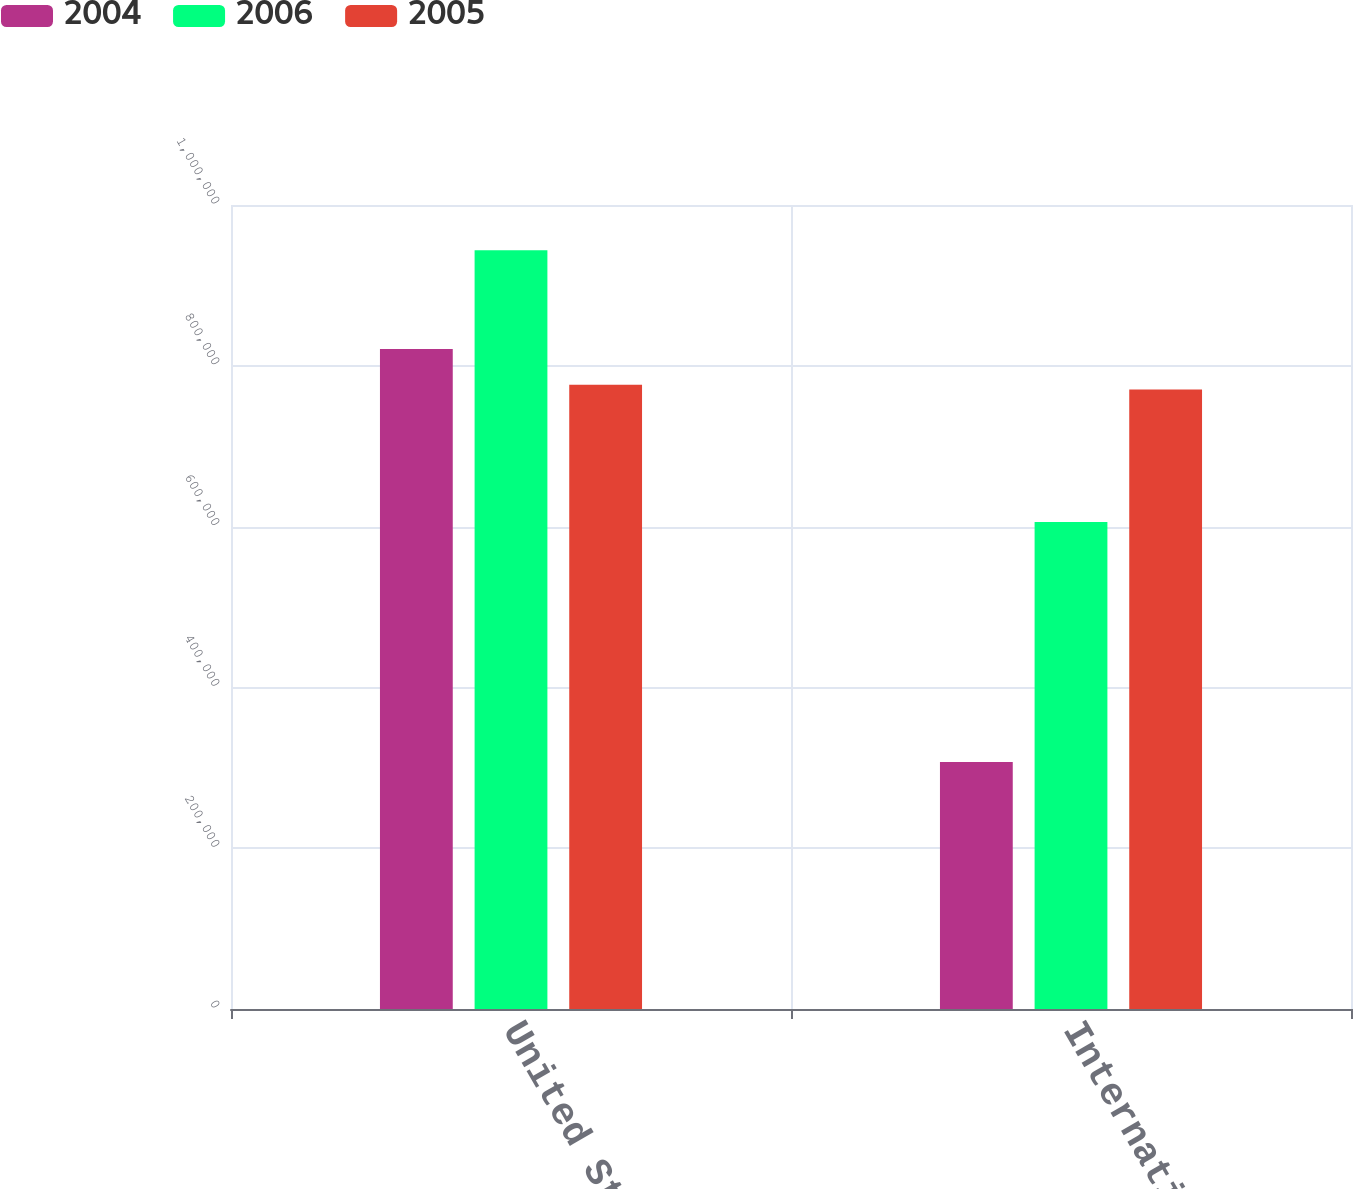<chart> <loc_0><loc_0><loc_500><loc_500><stacked_bar_chart><ecel><fcel>United States<fcel>International<nl><fcel>2004<fcel>820892<fcel>307338<nl><fcel>2006<fcel>943575<fcel>605802<nl><fcel>2005<fcel>776553<fcel>770509<nl></chart> 